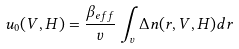<formula> <loc_0><loc_0><loc_500><loc_500>u _ { 0 } ( V , H ) = \frac { \beta _ { e f f } } { v } \int _ { v } \Delta n ( r , V , H ) d r</formula> 